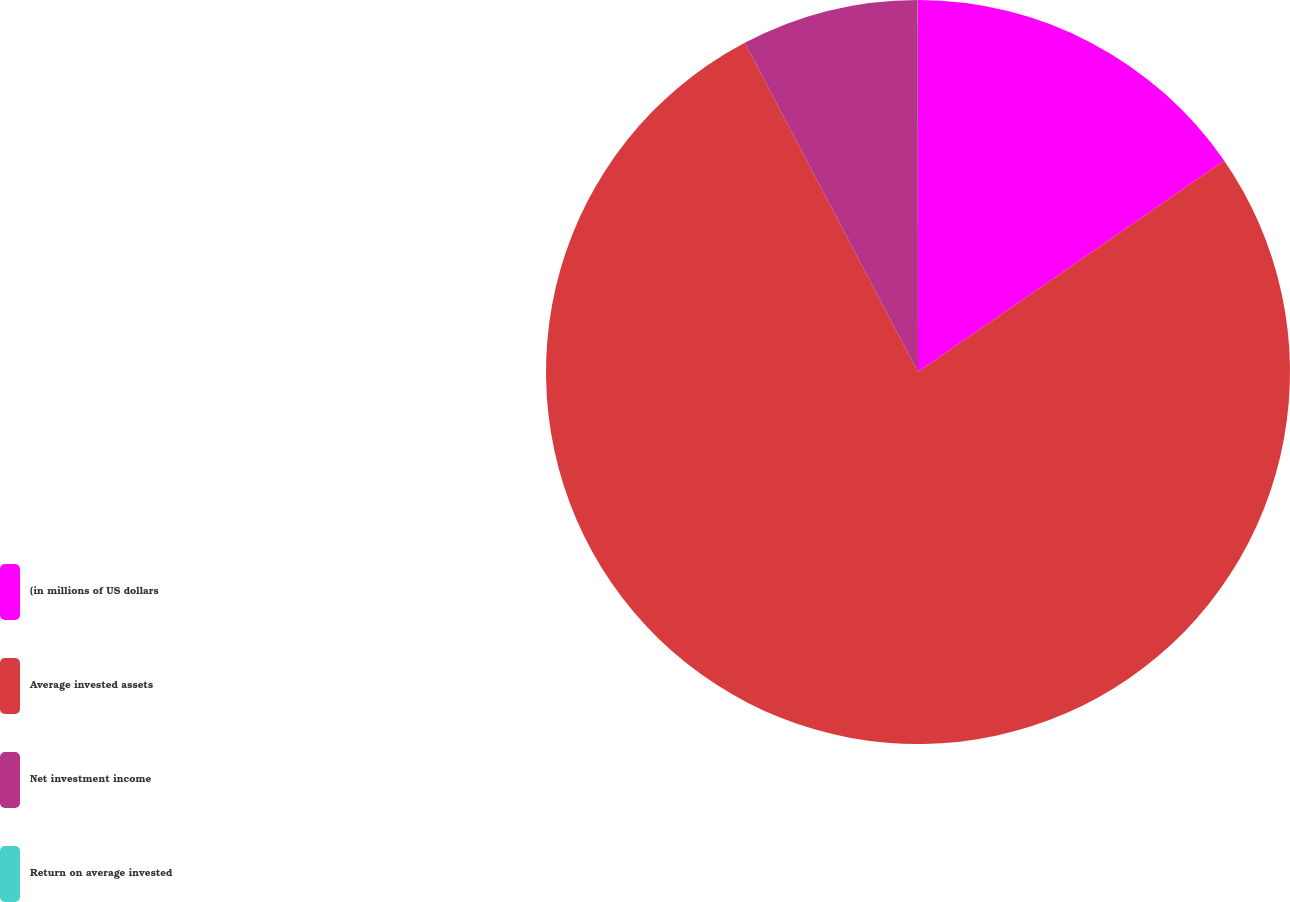<chart> <loc_0><loc_0><loc_500><loc_500><pie_chart><fcel>(in millions of US dollars<fcel>Average invested assets<fcel>Net investment income<fcel>Return on average invested<nl><fcel>15.39%<fcel>76.9%<fcel>7.7%<fcel>0.01%<nl></chart> 